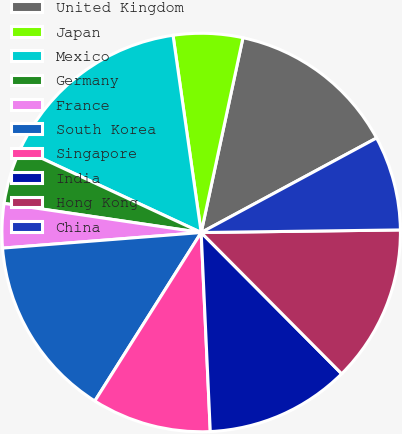Convert chart. <chart><loc_0><loc_0><loc_500><loc_500><pie_chart><fcel>United Kingdom<fcel>Japan<fcel>Mexico<fcel>Germany<fcel>France<fcel>South Korea<fcel>Singapore<fcel>India<fcel>Hong Kong<fcel>China<nl><fcel>13.77%<fcel>5.62%<fcel>15.81%<fcel>4.6%<fcel>3.58%<fcel>14.79%<fcel>9.69%<fcel>11.73%<fcel>12.75%<fcel>7.66%<nl></chart> 